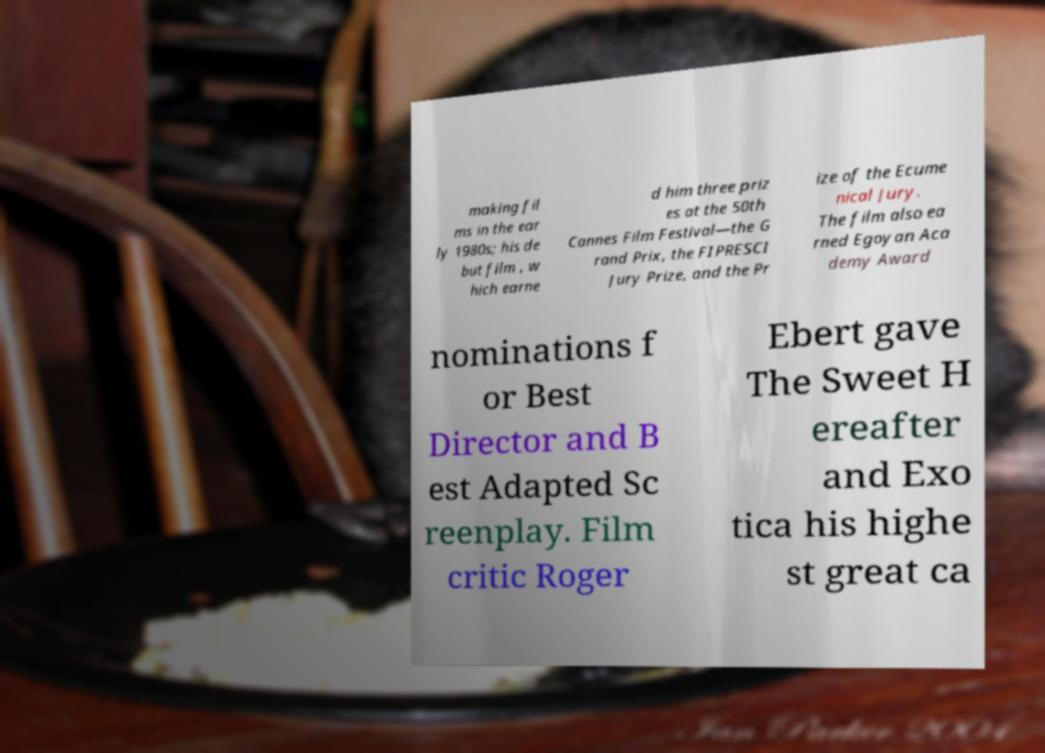Please identify and transcribe the text found in this image. making fil ms in the ear ly 1980s; his de but film , w hich earne d him three priz es at the 50th Cannes Film Festival—the G rand Prix, the FIPRESCI Jury Prize, and the Pr ize of the Ecume nical Jury. The film also ea rned Egoyan Aca demy Award nominations f or Best Director and B est Adapted Sc reenplay. Film critic Roger Ebert gave The Sweet H ereafter and Exo tica his highe st great ca 